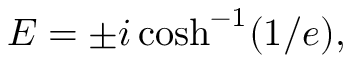Convert formula to latex. <formula><loc_0><loc_0><loc_500><loc_500>E = \pm i \cosh ^ { - 1 } ( 1 / e ) ,</formula> 